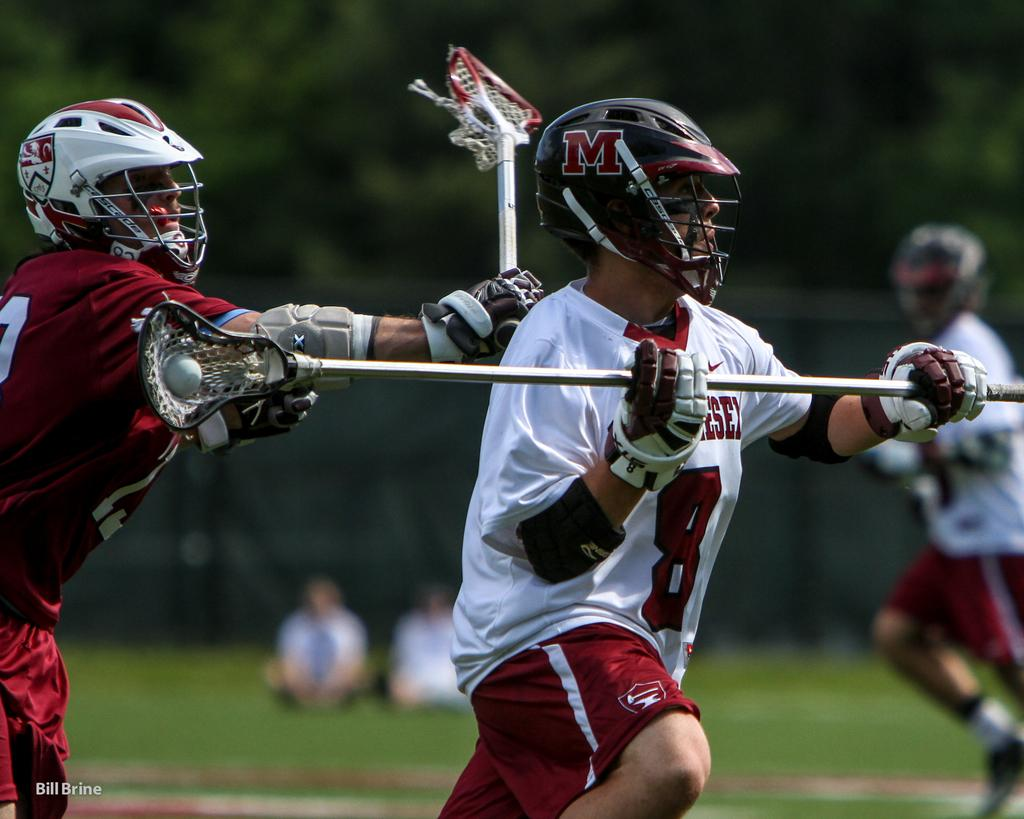What are the people in the image doing? The people in the image are playing a game. What action are the players taking in the game? The players are running in the ground. Can you describe the background of the image? The background of the image is blurry. What type of tooth can be seen in the image? There is no tooth present in the image. What pest is causing trouble for the players in the image? There is no pest present in the image; the players are focused on their game. 